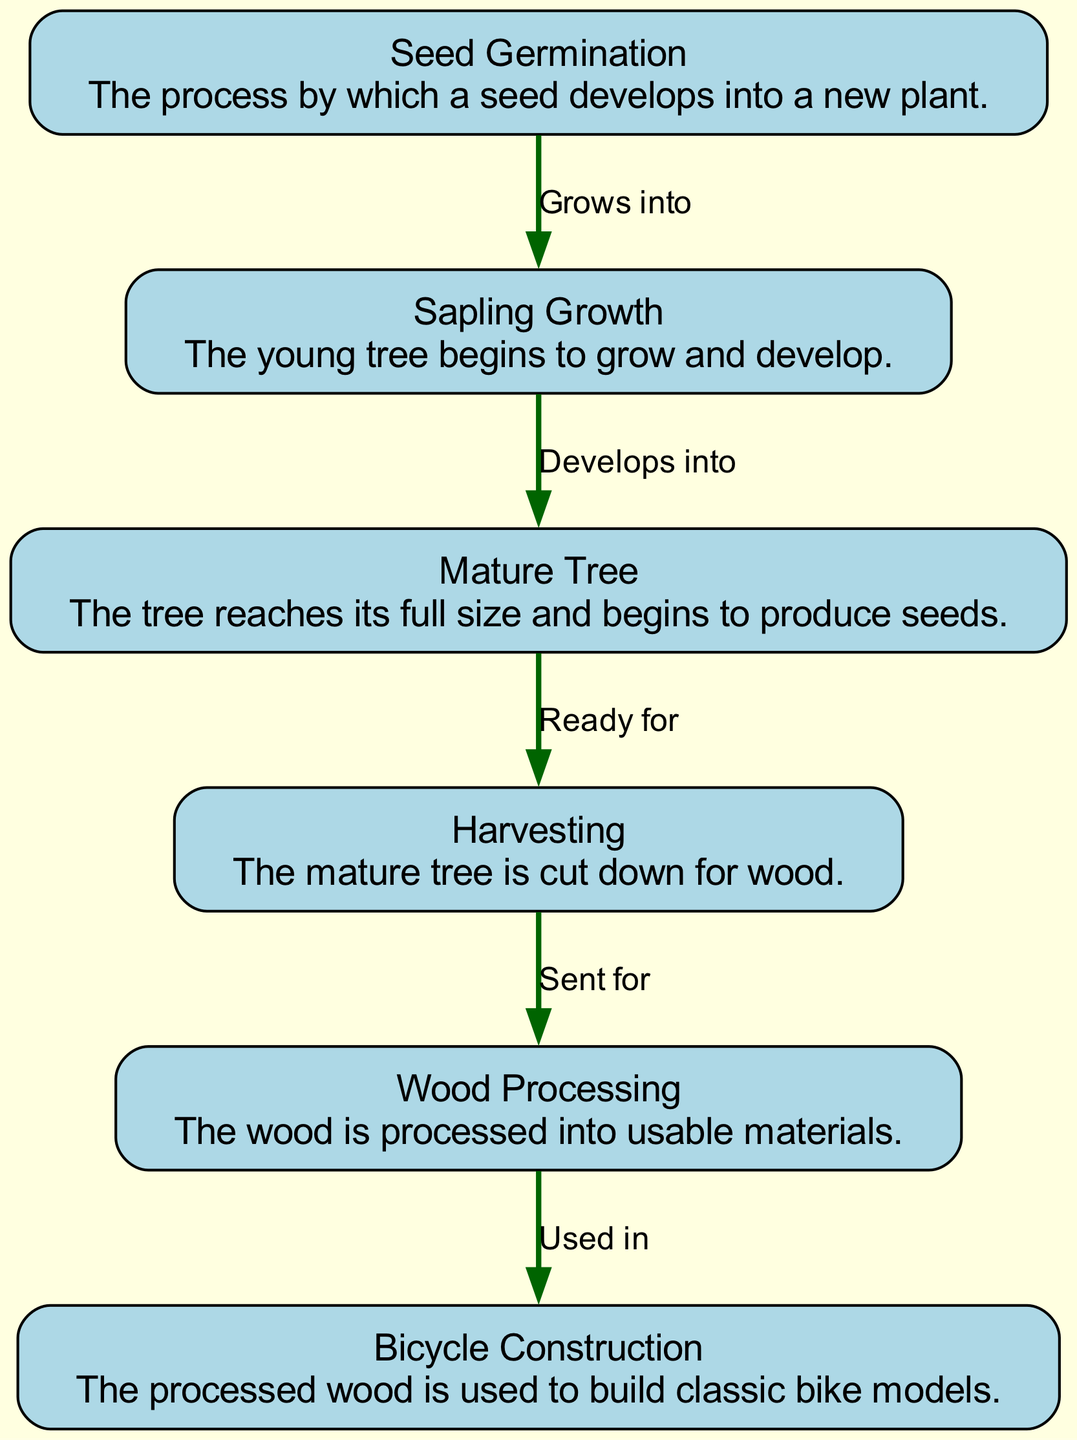What is the first stage of the tree's life cycle? The first stage is labeled as "Seed Germination," which is indicated clearly at the top of the diagram. This node describes the process by which a seed develops into a new plant.
Answer: Seed Germination How many nodes are present in the diagram? The diagram features a total of 6 nodes representing different stages in the life cycle of the vintage tree. Each stage is outlined in the diagram as distinct portions.
Answer: 6 What stage comes after Sapling Growth? According to the edges connected in the diagram, "Sapling Growth" is followed directly by "Mature Tree," as indicated by the edge labeled "Develops into."
Answer: Mature Tree What process follows the harvesting of the tree? After "Harvesting," the next process is "Wood Processing," which is shown by the edge labeled "Sent for." This indicates that the harvested tree is then transformed into usable materials.
Answer: Wood Processing Which stage represents when the tree reaches its full size? The stage known as "Mature Tree" signifies when the tree has achieved its full size and begins to produce seeds, as described in the diagram.
Answer: Mature Tree What is the relationship between "Wood Processing" and "Bicycle Construction"? The relationship is that the processed wood from "Wood Processing" is "Used in" the stage of "Bicycle Construction," as indicated by the connecting edge.
Answer: Used in How many edges are present in the diagram? Upon examining the diagram's structure, there are a total of 5 edges connecting the 6 nodes, representing the relationships between the various stages.
Answer: 5 What happens directly after the tree develops into a mature tree? The stage after the tree reaches its mature size is "Harvesting," indicated by the edge labeled "Ready for." This shows the transition from a mature tree to being cut down for wood.
Answer: Harvesting What is the overall purpose of this diagram? The diagram outlines the life cycle of a vintage tree and how its wood is utilized in the construction of classic bikes, demonstrating the interconnections between natural growth and human application in vintage bike culture.
Answer: Analyzing wood for classic bikes 